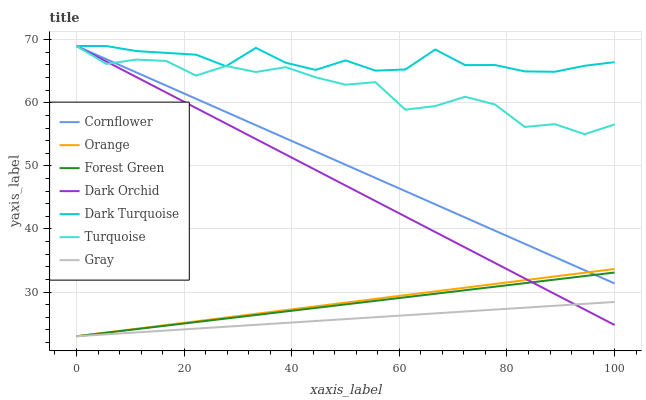Does Gray have the minimum area under the curve?
Answer yes or no. Yes. Does Dark Turquoise have the maximum area under the curve?
Answer yes or no. Yes. Does Turquoise have the minimum area under the curve?
Answer yes or no. No. Does Turquoise have the maximum area under the curve?
Answer yes or no. No. Is Orange the smoothest?
Answer yes or no. Yes. Is Turquoise the roughest?
Answer yes or no. Yes. Is Gray the smoothest?
Answer yes or no. No. Is Gray the roughest?
Answer yes or no. No. Does Gray have the lowest value?
Answer yes or no. Yes. Does Turquoise have the lowest value?
Answer yes or no. No. Does Dark Orchid have the highest value?
Answer yes or no. Yes. Does Gray have the highest value?
Answer yes or no. No. Is Forest Green less than Turquoise?
Answer yes or no. Yes. Is Dark Turquoise greater than Orange?
Answer yes or no. Yes. Does Turquoise intersect Dark Orchid?
Answer yes or no. Yes. Is Turquoise less than Dark Orchid?
Answer yes or no. No. Is Turquoise greater than Dark Orchid?
Answer yes or no. No. Does Forest Green intersect Turquoise?
Answer yes or no. No. 